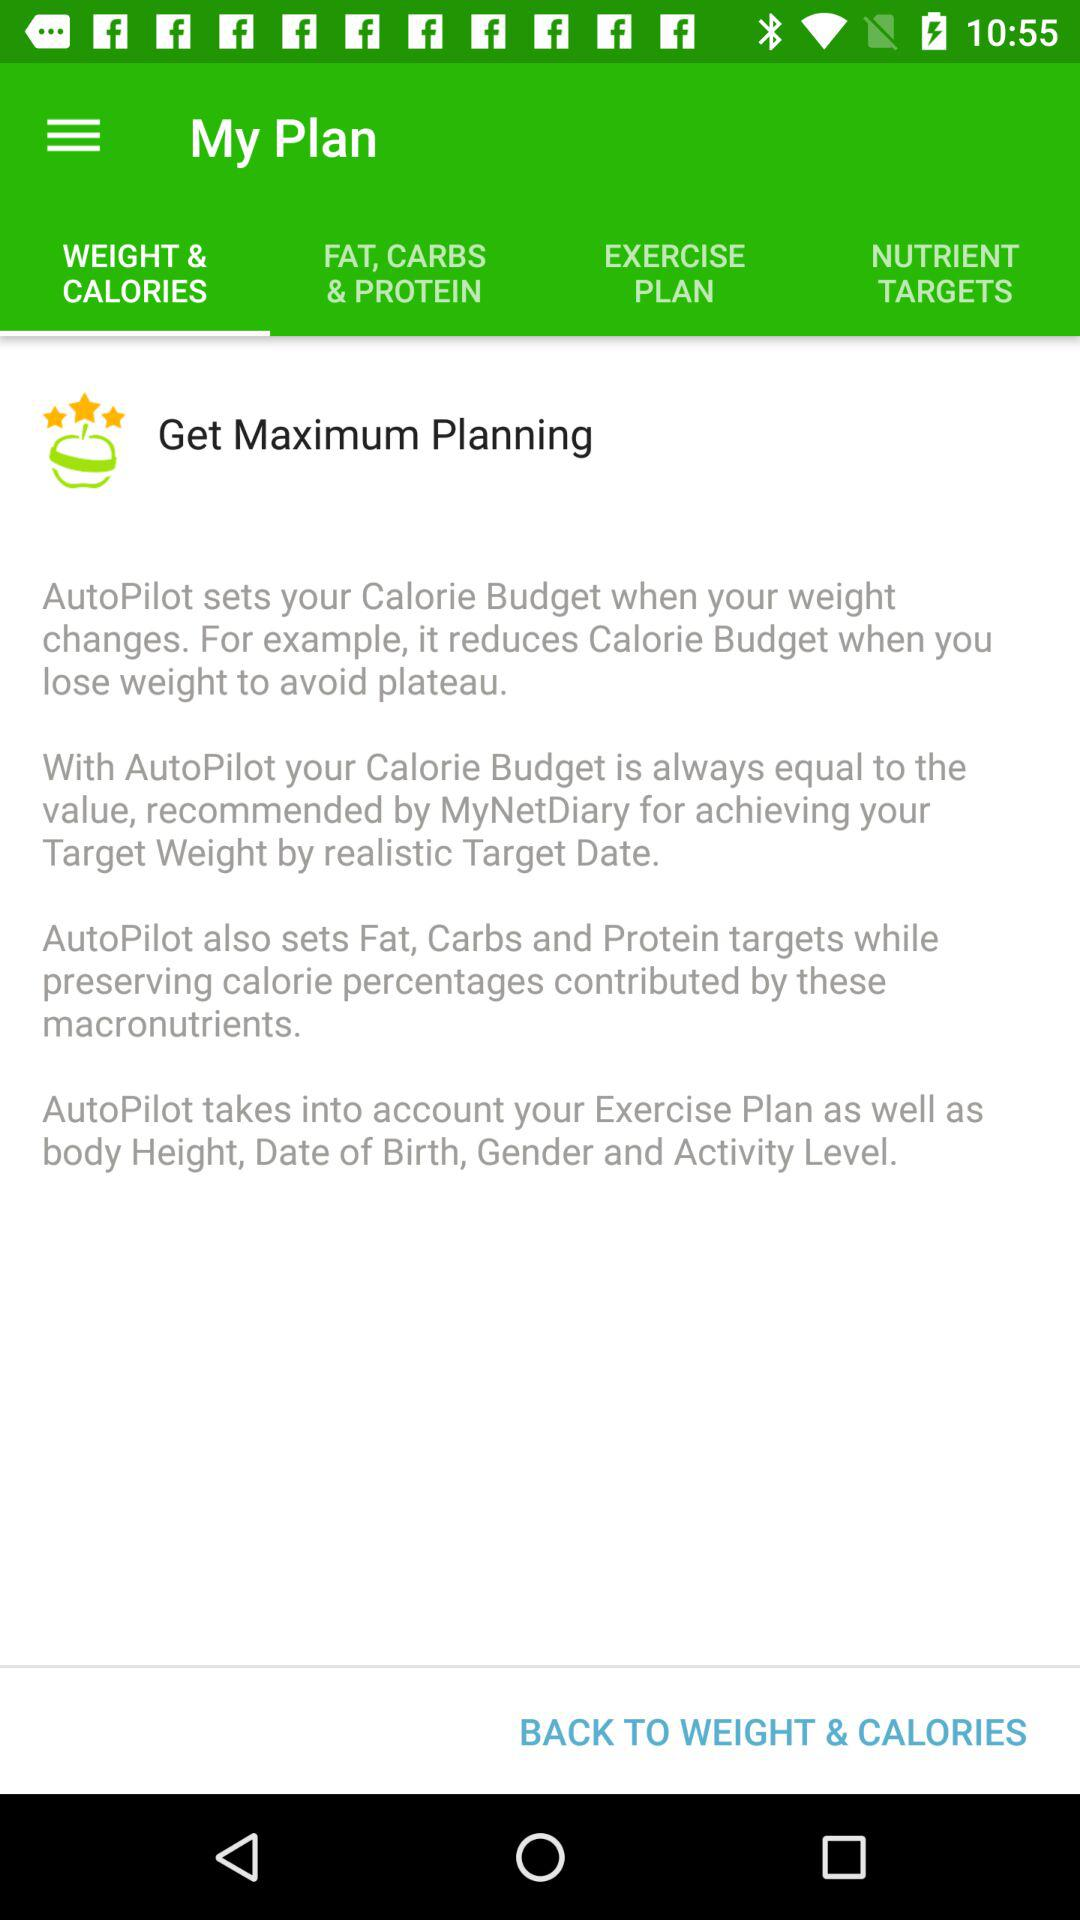Which tab is selected? The selected tab is "WEIGHT & CALORIES". 